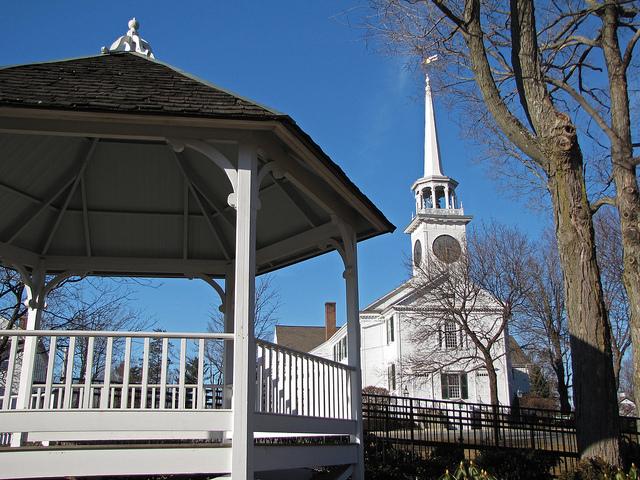What is the building with no walls called?
Quick response, please. Gazebo. What architectural structure is the subject of the foreground?
Give a very brief answer. Gazebo. Do the trees have leaves?
Answer briefly. No. Does the wood look to be bamboo?
Quick response, please. No. 